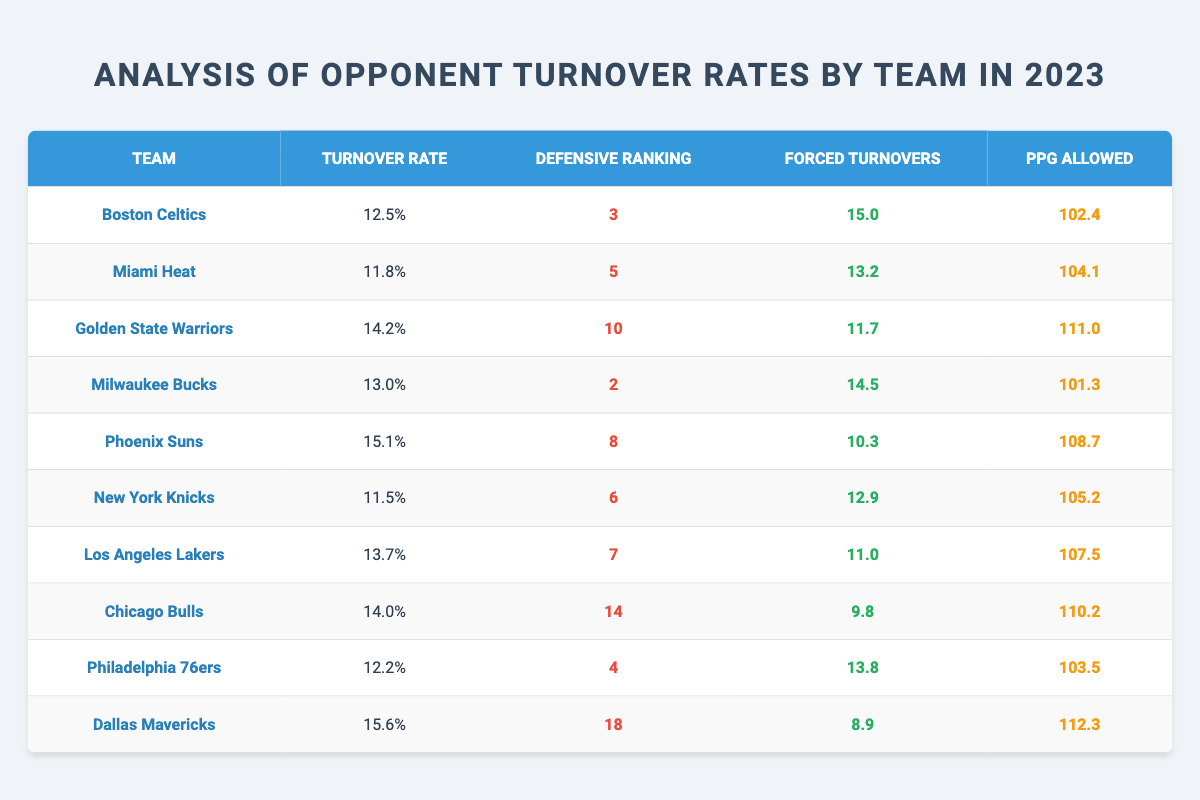What is the turnover rate of the Boston Celtics? The table shows that the Boston Celtics have a turnover rate of 12.5%.
Answer: 12.5% Which team has the highest turnover rate? By examining the table, the Dallas Mavericks have the highest turnover rate at 15.6%.
Answer: 15.6% What is the defensive ranking of the Milwaukee Bucks? The table indicates that the Milwaukee Bucks have a defensive ranking of 2.
Answer: 2 How many forced turnovers did the Miami Heat achieve? The Miami Heat forced 13.2 turnovers according to the table.
Answer: 13.2 What is the average turnover rate of the teams listed? To find the average, add all turnover rates (12.5 + 11.8 + 14.2 + 13.0 + 15.1 + 11.5 + 13.7 + 14.0 + 12.2 + 15.6) =  141.6; there are 10 teams, so the average is 141.6 / 10 = 14.16%.
Answer: 14.16% True or False: The Philadelphia 76ers allowed fewer points per game than the Chicago Bulls. The table lists that the 76ers allowed 103.5 ppg, while the Bulls allowed 110.2 ppg, making the statement false.
Answer: False Which team has the fewest forced turnovers? The Chicago Bulls have the fewest forced turnovers at 9.8, as listed in the table.
Answer: 9.8 What is the difference in forced turnovers between the Boston Celtics and the Dallas Mavericks? The Celtics forced 15.0 turnovers, while the Mavericks forced 8.9. The difference is calculated as 15.0 - 8.9 = 6.1.
Answer: 6.1 Which team has the best defensive ranking with the highest turnover rate? The Milwaukee Bucks are ranked 2nd defensively and have a turnover rate of 13.0%, making them the highest ranked team with a high turnover rate.
Answer: Milwaukee Bucks If we consider only the top three teams by defensive ranking, what is their average PPG allowed? The top three teams based on defensive ranking are the Milwaukee Bucks (101.3), Boston Celtics (102.4), and Miami Heat (104.1); the average is calculated as (101.3 + 102.4 + 104.1) / 3 = 102.6.
Answer: 102.6 